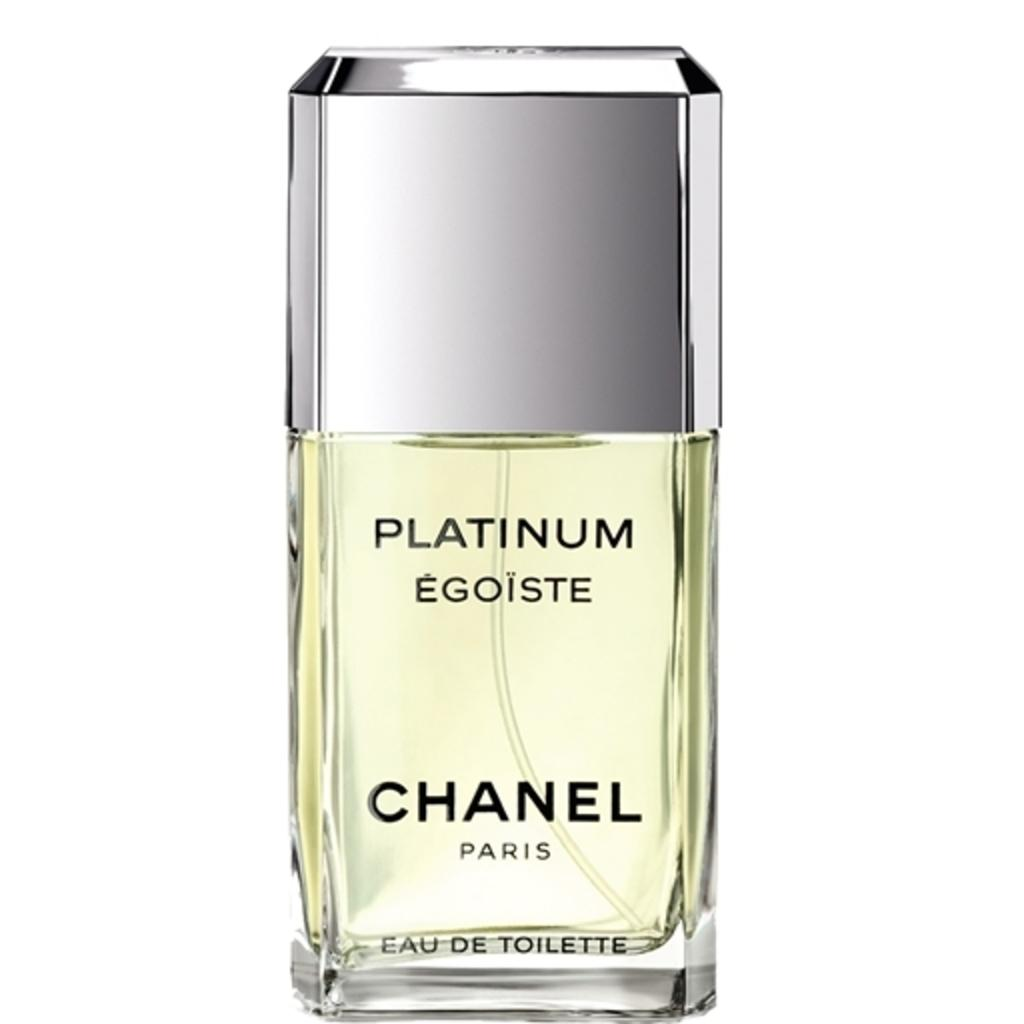<image>
Share a concise interpretation of the image provided. A bottle of Platinum Egoiste cologne  by Chanel Paris. 